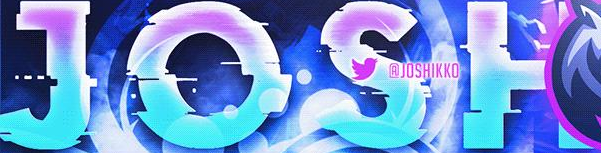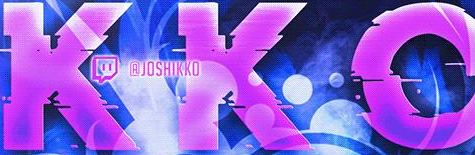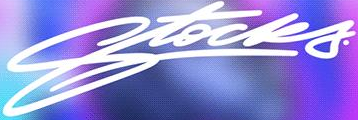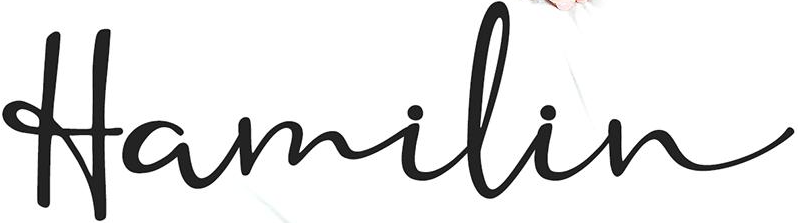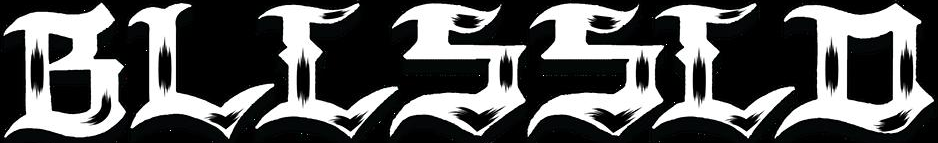What text is displayed in these images sequentially, separated by a semicolon? JOSH; KKO; Stocks; Hamilin; BLLSSLD 